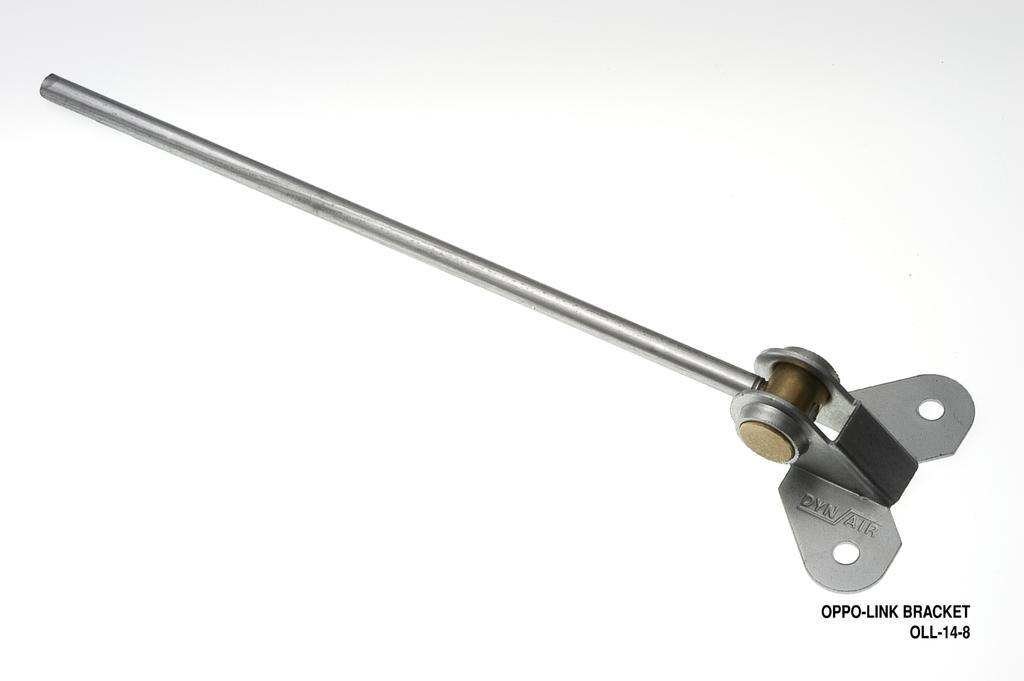What object in the image can be used as a tool? There is a tool in the image. What can be found on the right side of the image? There is text on the right side of the image. What color is the surface in the image? The surface in the image is white. How does the tool help with the expansion of the minute in the image? There is no mention of expansion or minute in the image, and the tool's purpose is not specified. 